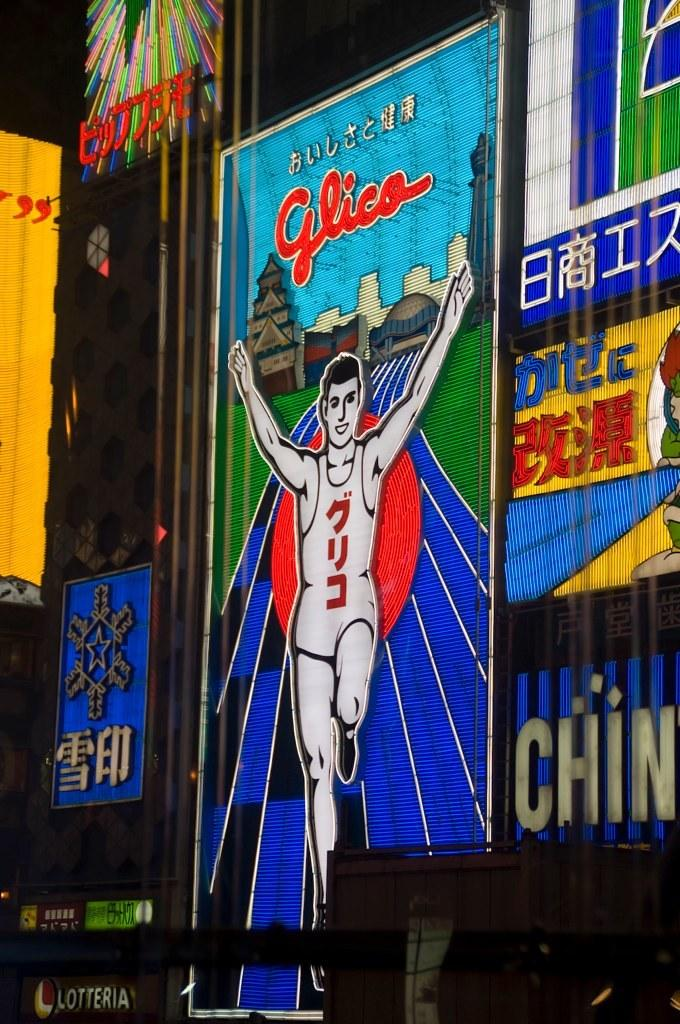<image>
Give a short and clear explanation of the subsequent image. Various signs on a billboard including an advertisement for Glico 